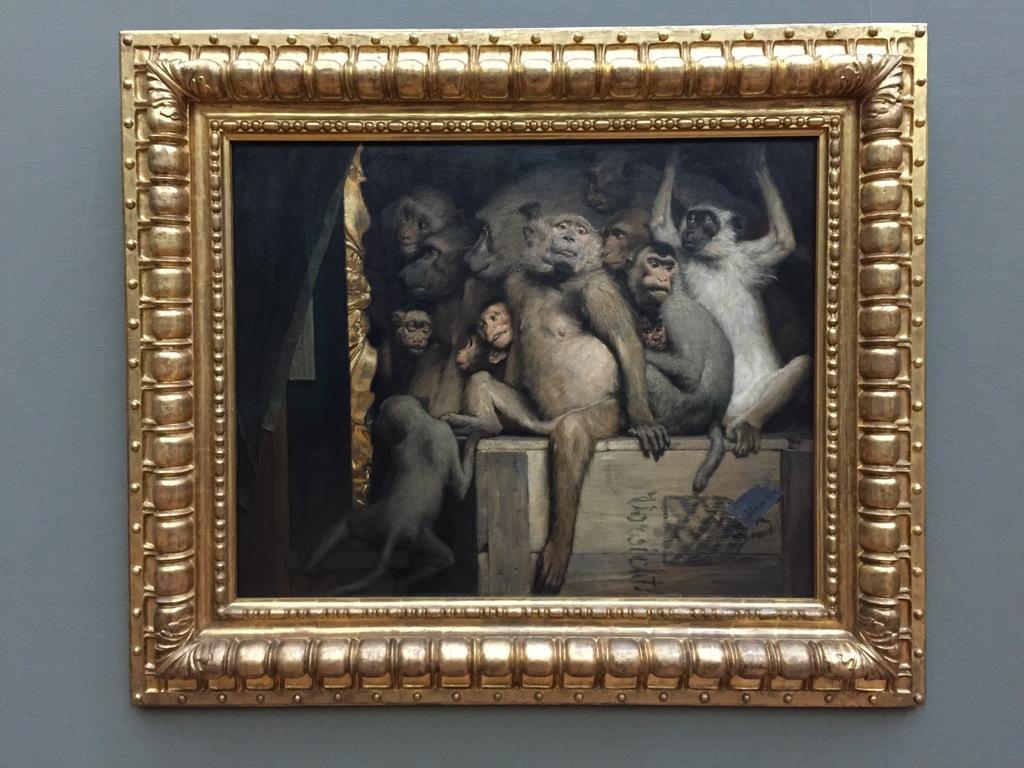Describe this image in one or two sentences. In the center of the image there is a photo frame in which there are many monkeys. At the background of the image there is a wall. 